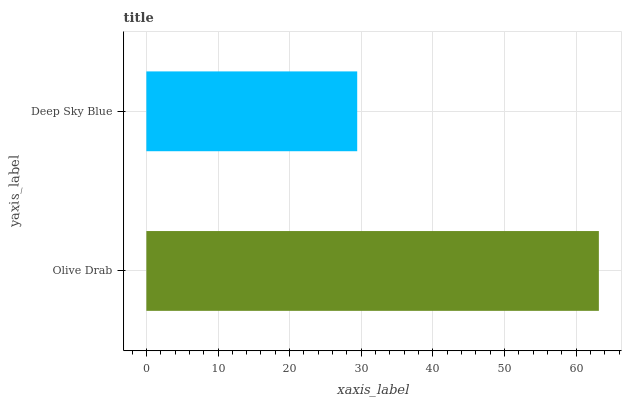Is Deep Sky Blue the minimum?
Answer yes or no. Yes. Is Olive Drab the maximum?
Answer yes or no. Yes. Is Deep Sky Blue the maximum?
Answer yes or no. No. Is Olive Drab greater than Deep Sky Blue?
Answer yes or no. Yes. Is Deep Sky Blue less than Olive Drab?
Answer yes or no. Yes. Is Deep Sky Blue greater than Olive Drab?
Answer yes or no. No. Is Olive Drab less than Deep Sky Blue?
Answer yes or no. No. Is Olive Drab the high median?
Answer yes or no. Yes. Is Deep Sky Blue the low median?
Answer yes or no. Yes. Is Deep Sky Blue the high median?
Answer yes or no. No. Is Olive Drab the low median?
Answer yes or no. No. 